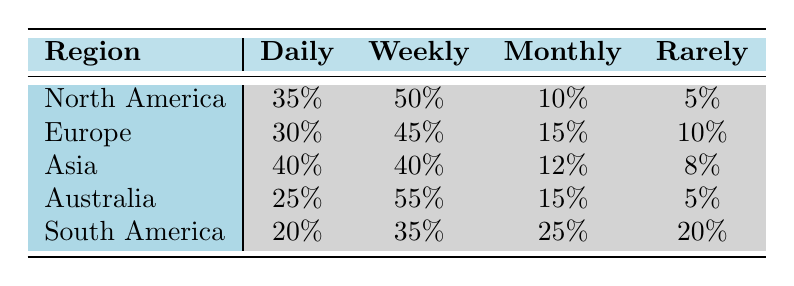What percentage of Asia's gamers play online multiplayer daily? According to the table, the percentage of Asia's gamers who play online multiplayer daily is listed directly under the "Daily" column for Asia. It shows that 40% of gamers in Asia engage in online multiplayer on a daily basis.
Answer: 40% Which region has the highest percentage of gamers who play online multiplayer weekly? By comparing the percentages under the "Weekly" column, Australia has the highest percentage of 55%, which is greater than all other regions listed for weekly online multiplayer gameplay.
Answer: Australia What is the total percentage of North American gamers that use online multiplayer at least monthly? To find this, we sum the percentages for "Daily," "Weekly," and "Monthly" for North America only. The calculation is 35% (Daily) + 50% (Weekly) + 10% (Monthly) = 95%. Thus, 95% of North American gamers engage in online multiplayer at least once a month.
Answer: 95% Is it true that South American gamers play online multiplayer daily more often than Australian gamers? Looking at the table, South America shows a daily percentage of 20%, while Australia shows 25%. Therefore, it is false that South American gamers play daily more often as 20% is less than 25%.
Answer: No What is the difference in the percentage of gamers who play online multiplayer rarely between South America and North America? From the table, South America has 20% of gamers who play rarely, while North America has 5%. The difference is calculated as 20% - 5% = 15%. Therefore, the difference in percentages is 15%.
Answer: 15% Which region has the lowest overall participation in online multiplayer across all categories? To find this, we can examine the total frequencies. Summing up all frequencies for South America: 20% (Daily) + 35% (Weekly) + 25% (Monthly) + 20% (Rarely) = 100%. No other region has lower total engagement based on the individual percentages listed. Hence, South America has the lowest overall participation.
Answer: South America What percentage of European gamers play online multiplayer at least weekly? For this, we sum the Weekly and Daily percentages for Europe: 30% (Daily) + 45% (Weekly) = 75%. Thus, 75% of European gamers use online multiplayer at least weekly.
Answer: 75% 